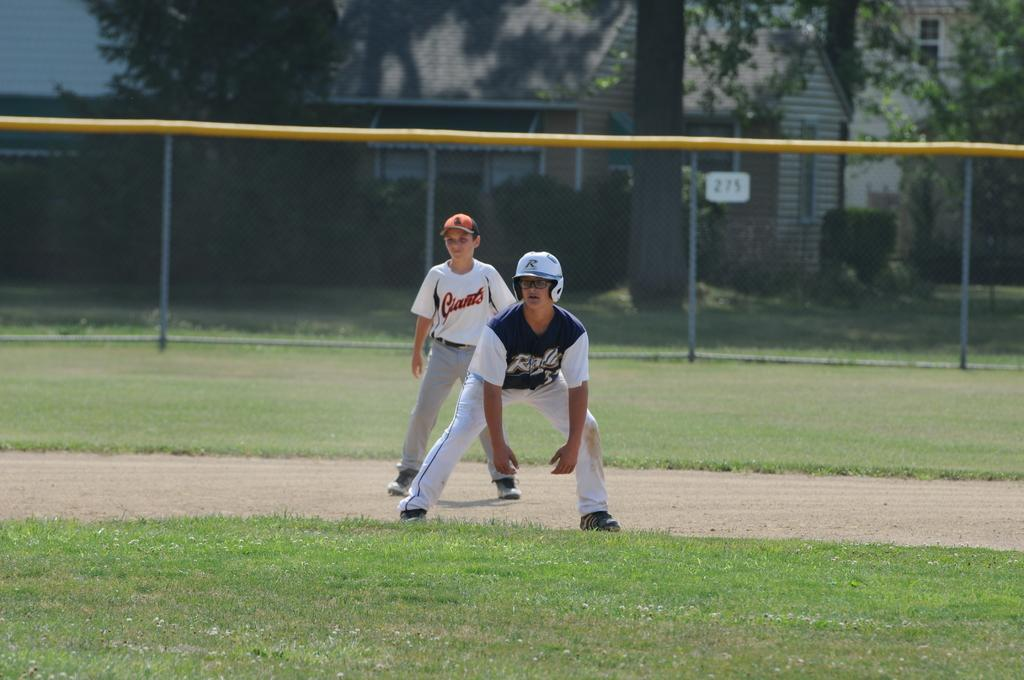<image>
Present a compact description of the photo's key features. the name Giants is on the jersey of the player on the field 